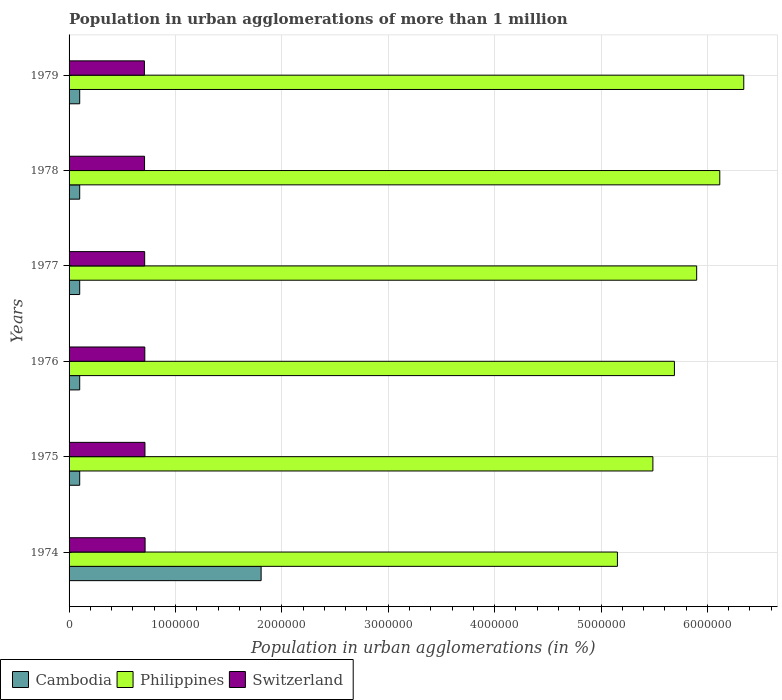How many different coloured bars are there?
Offer a terse response. 3. How many bars are there on the 2nd tick from the top?
Ensure brevity in your answer.  3. What is the label of the 1st group of bars from the top?
Offer a terse response. 1979. In how many cases, is the number of bars for a given year not equal to the number of legend labels?
Provide a succinct answer. 0. What is the population in urban agglomerations in Philippines in 1978?
Make the answer very short. 6.12e+06. Across all years, what is the maximum population in urban agglomerations in Switzerland?
Offer a terse response. 7.15e+05. Across all years, what is the minimum population in urban agglomerations in Philippines?
Offer a very short reply. 5.15e+06. In which year was the population in urban agglomerations in Cambodia maximum?
Your response must be concise. 1974. In which year was the population in urban agglomerations in Philippines minimum?
Offer a very short reply. 1974. What is the total population in urban agglomerations in Switzerland in the graph?
Your response must be concise. 4.27e+06. What is the difference between the population in urban agglomerations in Cambodia in 1978 and the population in urban agglomerations in Philippines in 1976?
Provide a succinct answer. -5.59e+06. What is the average population in urban agglomerations in Cambodia per year?
Keep it short and to the point. 3.84e+05. In the year 1976, what is the difference between the population in urban agglomerations in Switzerland and population in urban agglomerations in Cambodia?
Keep it short and to the point. 6.12e+05. What is the difference between the highest and the second highest population in urban agglomerations in Cambodia?
Ensure brevity in your answer.  1.71e+06. What is the difference between the highest and the lowest population in urban agglomerations in Cambodia?
Offer a very short reply. 1.71e+06. What does the 2nd bar from the top in 1979 represents?
Your answer should be very brief. Philippines. Is it the case that in every year, the sum of the population in urban agglomerations in Switzerland and population in urban agglomerations in Cambodia is greater than the population in urban agglomerations in Philippines?
Keep it short and to the point. No. How many years are there in the graph?
Provide a succinct answer. 6. Are the values on the major ticks of X-axis written in scientific E-notation?
Offer a very short reply. No. How many legend labels are there?
Make the answer very short. 3. What is the title of the graph?
Provide a succinct answer. Population in urban agglomerations of more than 1 million. Does "American Samoa" appear as one of the legend labels in the graph?
Your answer should be compact. No. What is the label or title of the X-axis?
Make the answer very short. Population in urban agglomerations (in %). What is the label or title of the Y-axis?
Ensure brevity in your answer.  Years. What is the Population in urban agglomerations (in %) of Cambodia in 1974?
Offer a terse response. 1.81e+06. What is the Population in urban agglomerations (in %) in Philippines in 1974?
Your answer should be compact. 5.15e+06. What is the Population in urban agglomerations (in %) in Switzerland in 1974?
Your answer should be very brief. 7.15e+05. What is the Population in urban agglomerations (in %) of Philippines in 1975?
Provide a succinct answer. 5.49e+06. What is the Population in urban agglomerations (in %) of Switzerland in 1975?
Your answer should be very brief. 7.13e+05. What is the Population in urban agglomerations (in %) in Cambodia in 1976?
Offer a very short reply. 1.00e+05. What is the Population in urban agglomerations (in %) in Philippines in 1976?
Make the answer very short. 5.69e+06. What is the Population in urban agglomerations (in %) in Switzerland in 1976?
Ensure brevity in your answer.  7.12e+05. What is the Population in urban agglomerations (in %) of Philippines in 1977?
Ensure brevity in your answer.  5.90e+06. What is the Population in urban agglomerations (in %) of Switzerland in 1977?
Ensure brevity in your answer.  7.11e+05. What is the Population in urban agglomerations (in %) of Philippines in 1978?
Ensure brevity in your answer.  6.12e+06. What is the Population in urban agglomerations (in %) of Switzerland in 1978?
Your answer should be compact. 7.09e+05. What is the Population in urban agglomerations (in %) in Philippines in 1979?
Give a very brief answer. 6.34e+06. What is the Population in urban agglomerations (in %) of Switzerland in 1979?
Provide a short and direct response. 7.08e+05. Across all years, what is the maximum Population in urban agglomerations (in %) in Cambodia?
Offer a very short reply. 1.81e+06. Across all years, what is the maximum Population in urban agglomerations (in %) of Philippines?
Offer a very short reply. 6.34e+06. Across all years, what is the maximum Population in urban agglomerations (in %) of Switzerland?
Your response must be concise. 7.15e+05. Across all years, what is the minimum Population in urban agglomerations (in %) of Philippines?
Make the answer very short. 5.15e+06. Across all years, what is the minimum Population in urban agglomerations (in %) in Switzerland?
Your answer should be very brief. 7.08e+05. What is the total Population in urban agglomerations (in %) of Cambodia in the graph?
Offer a terse response. 2.31e+06. What is the total Population in urban agglomerations (in %) of Philippines in the graph?
Keep it short and to the point. 3.47e+07. What is the total Population in urban agglomerations (in %) of Switzerland in the graph?
Keep it short and to the point. 4.27e+06. What is the difference between the Population in urban agglomerations (in %) of Cambodia in 1974 and that in 1975?
Give a very brief answer. 1.71e+06. What is the difference between the Population in urban agglomerations (in %) of Philippines in 1974 and that in 1975?
Offer a very short reply. -3.33e+05. What is the difference between the Population in urban agglomerations (in %) of Switzerland in 1974 and that in 1975?
Offer a terse response. 1312. What is the difference between the Population in urban agglomerations (in %) of Cambodia in 1974 and that in 1976?
Give a very brief answer. 1.71e+06. What is the difference between the Population in urban agglomerations (in %) of Philippines in 1974 and that in 1976?
Make the answer very short. -5.36e+05. What is the difference between the Population in urban agglomerations (in %) of Switzerland in 1974 and that in 1976?
Your response must be concise. 2623. What is the difference between the Population in urban agglomerations (in %) in Cambodia in 1974 and that in 1977?
Offer a very short reply. 1.71e+06. What is the difference between the Population in urban agglomerations (in %) in Philippines in 1974 and that in 1977?
Ensure brevity in your answer.  -7.45e+05. What is the difference between the Population in urban agglomerations (in %) of Switzerland in 1974 and that in 1977?
Your response must be concise. 3929. What is the difference between the Population in urban agglomerations (in %) of Cambodia in 1974 and that in 1978?
Your answer should be compact. 1.71e+06. What is the difference between the Population in urban agglomerations (in %) in Philippines in 1974 and that in 1978?
Provide a succinct answer. -9.62e+05. What is the difference between the Population in urban agglomerations (in %) in Switzerland in 1974 and that in 1978?
Make the answer very short. 5234. What is the difference between the Population in urban agglomerations (in %) in Cambodia in 1974 and that in 1979?
Make the answer very short. 1.71e+06. What is the difference between the Population in urban agglomerations (in %) in Philippines in 1974 and that in 1979?
Your response must be concise. -1.19e+06. What is the difference between the Population in urban agglomerations (in %) in Switzerland in 1974 and that in 1979?
Your response must be concise. 6537. What is the difference between the Population in urban agglomerations (in %) in Philippines in 1975 and that in 1976?
Offer a very short reply. -2.02e+05. What is the difference between the Population in urban agglomerations (in %) of Switzerland in 1975 and that in 1976?
Offer a very short reply. 1311. What is the difference between the Population in urban agglomerations (in %) in Philippines in 1975 and that in 1977?
Your response must be concise. -4.11e+05. What is the difference between the Population in urban agglomerations (in %) of Switzerland in 1975 and that in 1977?
Keep it short and to the point. 2617. What is the difference between the Population in urban agglomerations (in %) of Cambodia in 1975 and that in 1978?
Keep it short and to the point. 0. What is the difference between the Population in urban agglomerations (in %) of Philippines in 1975 and that in 1978?
Your answer should be very brief. -6.29e+05. What is the difference between the Population in urban agglomerations (in %) of Switzerland in 1975 and that in 1978?
Provide a succinct answer. 3922. What is the difference between the Population in urban agglomerations (in %) in Philippines in 1975 and that in 1979?
Keep it short and to the point. -8.54e+05. What is the difference between the Population in urban agglomerations (in %) in Switzerland in 1975 and that in 1979?
Give a very brief answer. 5225. What is the difference between the Population in urban agglomerations (in %) in Cambodia in 1976 and that in 1977?
Your response must be concise. 0. What is the difference between the Population in urban agglomerations (in %) in Philippines in 1976 and that in 1977?
Provide a succinct answer. -2.09e+05. What is the difference between the Population in urban agglomerations (in %) of Switzerland in 1976 and that in 1977?
Your answer should be very brief. 1306. What is the difference between the Population in urban agglomerations (in %) in Philippines in 1976 and that in 1978?
Provide a short and direct response. -4.26e+05. What is the difference between the Population in urban agglomerations (in %) of Switzerland in 1976 and that in 1978?
Your answer should be compact. 2611. What is the difference between the Population in urban agglomerations (in %) of Philippines in 1976 and that in 1979?
Provide a short and direct response. -6.52e+05. What is the difference between the Population in urban agglomerations (in %) in Switzerland in 1976 and that in 1979?
Ensure brevity in your answer.  3914. What is the difference between the Population in urban agglomerations (in %) of Philippines in 1977 and that in 1978?
Provide a short and direct response. -2.17e+05. What is the difference between the Population in urban agglomerations (in %) in Switzerland in 1977 and that in 1978?
Your answer should be very brief. 1305. What is the difference between the Population in urban agglomerations (in %) of Cambodia in 1977 and that in 1979?
Your answer should be very brief. 0. What is the difference between the Population in urban agglomerations (in %) in Philippines in 1977 and that in 1979?
Your answer should be compact. -4.43e+05. What is the difference between the Population in urban agglomerations (in %) in Switzerland in 1977 and that in 1979?
Offer a very short reply. 2608. What is the difference between the Population in urban agglomerations (in %) in Philippines in 1978 and that in 1979?
Offer a terse response. -2.25e+05. What is the difference between the Population in urban agglomerations (in %) of Switzerland in 1978 and that in 1979?
Provide a succinct answer. 1303. What is the difference between the Population in urban agglomerations (in %) of Cambodia in 1974 and the Population in urban agglomerations (in %) of Philippines in 1975?
Keep it short and to the point. -3.68e+06. What is the difference between the Population in urban agglomerations (in %) of Cambodia in 1974 and the Population in urban agglomerations (in %) of Switzerland in 1975?
Keep it short and to the point. 1.09e+06. What is the difference between the Population in urban agglomerations (in %) in Philippines in 1974 and the Population in urban agglomerations (in %) in Switzerland in 1975?
Your answer should be compact. 4.44e+06. What is the difference between the Population in urban agglomerations (in %) in Cambodia in 1974 and the Population in urban agglomerations (in %) in Philippines in 1976?
Your answer should be compact. -3.88e+06. What is the difference between the Population in urban agglomerations (in %) of Cambodia in 1974 and the Population in urban agglomerations (in %) of Switzerland in 1976?
Make the answer very short. 1.09e+06. What is the difference between the Population in urban agglomerations (in %) in Philippines in 1974 and the Population in urban agglomerations (in %) in Switzerland in 1976?
Provide a succinct answer. 4.44e+06. What is the difference between the Population in urban agglomerations (in %) in Cambodia in 1974 and the Population in urban agglomerations (in %) in Philippines in 1977?
Offer a terse response. -4.09e+06. What is the difference between the Population in urban agglomerations (in %) in Cambodia in 1974 and the Population in urban agglomerations (in %) in Switzerland in 1977?
Offer a very short reply. 1.09e+06. What is the difference between the Population in urban agglomerations (in %) in Philippines in 1974 and the Population in urban agglomerations (in %) in Switzerland in 1977?
Provide a short and direct response. 4.44e+06. What is the difference between the Population in urban agglomerations (in %) of Cambodia in 1974 and the Population in urban agglomerations (in %) of Philippines in 1978?
Ensure brevity in your answer.  -4.31e+06. What is the difference between the Population in urban agglomerations (in %) in Cambodia in 1974 and the Population in urban agglomerations (in %) in Switzerland in 1978?
Make the answer very short. 1.10e+06. What is the difference between the Population in urban agglomerations (in %) in Philippines in 1974 and the Population in urban agglomerations (in %) in Switzerland in 1978?
Your answer should be compact. 4.44e+06. What is the difference between the Population in urban agglomerations (in %) in Cambodia in 1974 and the Population in urban agglomerations (in %) in Philippines in 1979?
Your answer should be very brief. -4.54e+06. What is the difference between the Population in urban agglomerations (in %) of Cambodia in 1974 and the Population in urban agglomerations (in %) of Switzerland in 1979?
Offer a terse response. 1.10e+06. What is the difference between the Population in urban agglomerations (in %) in Philippines in 1974 and the Population in urban agglomerations (in %) in Switzerland in 1979?
Your answer should be compact. 4.45e+06. What is the difference between the Population in urban agglomerations (in %) in Cambodia in 1975 and the Population in urban agglomerations (in %) in Philippines in 1976?
Provide a short and direct response. -5.59e+06. What is the difference between the Population in urban agglomerations (in %) in Cambodia in 1975 and the Population in urban agglomerations (in %) in Switzerland in 1976?
Your response must be concise. -6.12e+05. What is the difference between the Population in urban agglomerations (in %) in Philippines in 1975 and the Population in urban agglomerations (in %) in Switzerland in 1976?
Make the answer very short. 4.78e+06. What is the difference between the Population in urban agglomerations (in %) of Cambodia in 1975 and the Population in urban agglomerations (in %) of Philippines in 1977?
Your answer should be compact. -5.80e+06. What is the difference between the Population in urban agglomerations (in %) of Cambodia in 1975 and the Population in urban agglomerations (in %) of Switzerland in 1977?
Offer a very short reply. -6.11e+05. What is the difference between the Population in urban agglomerations (in %) of Philippines in 1975 and the Population in urban agglomerations (in %) of Switzerland in 1977?
Offer a very short reply. 4.78e+06. What is the difference between the Population in urban agglomerations (in %) of Cambodia in 1975 and the Population in urban agglomerations (in %) of Philippines in 1978?
Your answer should be compact. -6.02e+06. What is the difference between the Population in urban agglomerations (in %) in Cambodia in 1975 and the Population in urban agglomerations (in %) in Switzerland in 1978?
Your answer should be very brief. -6.09e+05. What is the difference between the Population in urban agglomerations (in %) in Philippines in 1975 and the Population in urban agglomerations (in %) in Switzerland in 1978?
Your answer should be very brief. 4.78e+06. What is the difference between the Population in urban agglomerations (in %) of Cambodia in 1975 and the Population in urban agglomerations (in %) of Philippines in 1979?
Provide a short and direct response. -6.24e+06. What is the difference between the Population in urban agglomerations (in %) of Cambodia in 1975 and the Population in urban agglomerations (in %) of Switzerland in 1979?
Your answer should be very brief. -6.08e+05. What is the difference between the Population in urban agglomerations (in %) of Philippines in 1975 and the Population in urban agglomerations (in %) of Switzerland in 1979?
Give a very brief answer. 4.78e+06. What is the difference between the Population in urban agglomerations (in %) in Cambodia in 1976 and the Population in urban agglomerations (in %) in Philippines in 1977?
Offer a terse response. -5.80e+06. What is the difference between the Population in urban agglomerations (in %) of Cambodia in 1976 and the Population in urban agglomerations (in %) of Switzerland in 1977?
Make the answer very short. -6.11e+05. What is the difference between the Population in urban agglomerations (in %) in Philippines in 1976 and the Population in urban agglomerations (in %) in Switzerland in 1977?
Offer a very short reply. 4.98e+06. What is the difference between the Population in urban agglomerations (in %) of Cambodia in 1976 and the Population in urban agglomerations (in %) of Philippines in 1978?
Make the answer very short. -6.02e+06. What is the difference between the Population in urban agglomerations (in %) in Cambodia in 1976 and the Population in urban agglomerations (in %) in Switzerland in 1978?
Your answer should be very brief. -6.09e+05. What is the difference between the Population in urban agglomerations (in %) of Philippines in 1976 and the Population in urban agglomerations (in %) of Switzerland in 1978?
Offer a terse response. 4.98e+06. What is the difference between the Population in urban agglomerations (in %) of Cambodia in 1976 and the Population in urban agglomerations (in %) of Philippines in 1979?
Your answer should be compact. -6.24e+06. What is the difference between the Population in urban agglomerations (in %) of Cambodia in 1976 and the Population in urban agglomerations (in %) of Switzerland in 1979?
Your answer should be very brief. -6.08e+05. What is the difference between the Population in urban agglomerations (in %) in Philippines in 1976 and the Population in urban agglomerations (in %) in Switzerland in 1979?
Your answer should be compact. 4.98e+06. What is the difference between the Population in urban agglomerations (in %) in Cambodia in 1977 and the Population in urban agglomerations (in %) in Philippines in 1978?
Ensure brevity in your answer.  -6.02e+06. What is the difference between the Population in urban agglomerations (in %) in Cambodia in 1977 and the Population in urban agglomerations (in %) in Switzerland in 1978?
Offer a very short reply. -6.09e+05. What is the difference between the Population in urban agglomerations (in %) of Philippines in 1977 and the Population in urban agglomerations (in %) of Switzerland in 1978?
Make the answer very short. 5.19e+06. What is the difference between the Population in urban agglomerations (in %) in Cambodia in 1977 and the Population in urban agglomerations (in %) in Philippines in 1979?
Keep it short and to the point. -6.24e+06. What is the difference between the Population in urban agglomerations (in %) of Cambodia in 1977 and the Population in urban agglomerations (in %) of Switzerland in 1979?
Offer a terse response. -6.08e+05. What is the difference between the Population in urban agglomerations (in %) in Philippines in 1977 and the Population in urban agglomerations (in %) in Switzerland in 1979?
Give a very brief answer. 5.19e+06. What is the difference between the Population in urban agglomerations (in %) in Cambodia in 1978 and the Population in urban agglomerations (in %) in Philippines in 1979?
Keep it short and to the point. -6.24e+06. What is the difference between the Population in urban agglomerations (in %) of Cambodia in 1978 and the Population in urban agglomerations (in %) of Switzerland in 1979?
Your answer should be compact. -6.08e+05. What is the difference between the Population in urban agglomerations (in %) of Philippines in 1978 and the Population in urban agglomerations (in %) of Switzerland in 1979?
Make the answer very short. 5.41e+06. What is the average Population in urban agglomerations (in %) of Cambodia per year?
Your answer should be very brief. 3.84e+05. What is the average Population in urban agglomerations (in %) in Philippines per year?
Your answer should be very brief. 5.78e+06. What is the average Population in urban agglomerations (in %) in Switzerland per year?
Ensure brevity in your answer.  7.11e+05. In the year 1974, what is the difference between the Population in urban agglomerations (in %) of Cambodia and Population in urban agglomerations (in %) of Philippines?
Offer a very short reply. -3.35e+06. In the year 1974, what is the difference between the Population in urban agglomerations (in %) in Cambodia and Population in urban agglomerations (in %) in Switzerland?
Provide a short and direct response. 1.09e+06. In the year 1974, what is the difference between the Population in urban agglomerations (in %) of Philippines and Population in urban agglomerations (in %) of Switzerland?
Your answer should be compact. 4.44e+06. In the year 1975, what is the difference between the Population in urban agglomerations (in %) of Cambodia and Population in urban agglomerations (in %) of Philippines?
Keep it short and to the point. -5.39e+06. In the year 1975, what is the difference between the Population in urban agglomerations (in %) of Cambodia and Population in urban agglomerations (in %) of Switzerland?
Your answer should be very brief. -6.13e+05. In the year 1975, what is the difference between the Population in urban agglomerations (in %) in Philippines and Population in urban agglomerations (in %) in Switzerland?
Ensure brevity in your answer.  4.77e+06. In the year 1976, what is the difference between the Population in urban agglomerations (in %) in Cambodia and Population in urban agglomerations (in %) in Philippines?
Your answer should be very brief. -5.59e+06. In the year 1976, what is the difference between the Population in urban agglomerations (in %) of Cambodia and Population in urban agglomerations (in %) of Switzerland?
Ensure brevity in your answer.  -6.12e+05. In the year 1976, what is the difference between the Population in urban agglomerations (in %) of Philippines and Population in urban agglomerations (in %) of Switzerland?
Provide a succinct answer. 4.98e+06. In the year 1977, what is the difference between the Population in urban agglomerations (in %) of Cambodia and Population in urban agglomerations (in %) of Philippines?
Give a very brief answer. -5.80e+06. In the year 1977, what is the difference between the Population in urban agglomerations (in %) of Cambodia and Population in urban agglomerations (in %) of Switzerland?
Ensure brevity in your answer.  -6.11e+05. In the year 1977, what is the difference between the Population in urban agglomerations (in %) of Philippines and Population in urban agglomerations (in %) of Switzerland?
Your answer should be very brief. 5.19e+06. In the year 1978, what is the difference between the Population in urban agglomerations (in %) of Cambodia and Population in urban agglomerations (in %) of Philippines?
Provide a short and direct response. -6.02e+06. In the year 1978, what is the difference between the Population in urban agglomerations (in %) of Cambodia and Population in urban agglomerations (in %) of Switzerland?
Keep it short and to the point. -6.09e+05. In the year 1978, what is the difference between the Population in urban agglomerations (in %) in Philippines and Population in urban agglomerations (in %) in Switzerland?
Ensure brevity in your answer.  5.41e+06. In the year 1979, what is the difference between the Population in urban agglomerations (in %) of Cambodia and Population in urban agglomerations (in %) of Philippines?
Keep it short and to the point. -6.24e+06. In the year 1979, what is the difference between the Population in urban agglomerations (in %) of Cambodia and Population in urban agglomerations (in %) of Switzerland?
Provide a short and direct response. -6.08e+05. In the year 1979, what is the difference between the Population in urban agglomerations (in %) in Philippines and Population in urban agglomerations (in %) in Switzerland?
Offer a very short reply. 5.63e+06. What is the ratio of the Population in urban agglomerations (in %) of Cambodia in 1974 to that in 1975?
Ensure brevity in your answer.  18.05. What is the ratio of the Population in urban agglomerations (in %) in Philippines in 1974 to that in 1975?
Give a very brief answer. 0.94. What is the ratio of the Population in urban agglomerations (in %) in Switzerland in 1974 to that in 1975?
Give a very brief answer. 1. What is the ratio of the Population in urban agglomerations (in %) in Cambodia in 1974 to that in 1976?
Provide a short and direct response. 18.05. What is the ratio of the Population in urban agglomerations (in %) of Philippines in 1974 to that in 1976?
Offer a very short reply. 0.91. What is the ratio of the Population in urban agglomerations (in %) in Switzerland in 1974 to that in 1976?
Offer a terse response. 1. What is the ratio of the Population in urban agglomerations (in %) in Cambodia in 1974 to that in 1977?
Offer a terse response. 18.05. What is the ratio of the Population in urban agglomerations (in %) of Philippines in 1974 to that in 1977?
Offer a terse response. 0.87. What is the ratio of the Population in urban agglomerations (in %) of Switzerland in 1974 to that in 1977?
Offer a very short reply. 1.01. What is the ratio of the Population in urban agglomerations (in %) of Cambodia in 1974 to that in 1978?
Give a very brief answer. 18.05. What is the ratio of the Population in urban agglomerations (in %) in Philippines in 1974 to that in 1978?
Make the answer very short. 0.84. What is the ratio of the Population in urban agglomerations (in %) of Switzerland in 1974 to that in 1978?
Ensure brevity in your answer.  1.01. What is the ratio of the Population in urban agglomerations (in %) in Cambodia in 1974 to that in 1979?
Ensure brevity in your answer.  18.05. What is the ratio of the Population in urban agglomerations (in %) of Philippines in 1974 to that in 1979?
Make the answer very short. 0.81. What is the ratio of the Population in urban agglomerations (in %) of Switzerland in 1974 to that in 1979?
Provide a succinct answer. 1.01. What is the ratio of the Population in urban agglomerations (in %) of Philippines in 1975 to that in 1976?
Your response must be concise. 0.96. What is the ratio of the Population in urban agglomerations (in %) in Cambodia in 1975 to that in 1977?
Provide a succinct answer. 1. What is the ratio of the Population in urban agglomerations (in %) in Philippines in 1975 to that in 1977?
Your answer should be very brief. 0.93. What is the ratio of the Population in urban agglomerations (in %) of Switzerland in 1975 to that in 1977?
Provide a short and direct response. 1. What is the ratio of the Population in urban agglomerations (in %) in Cambodia in 1975 to that in 1978?
Provide a short and direct response. 1. What is the ratio of the Population in urban agglomerations (in %) of Philippines in 1975 to that in 1978?
Keep it short and to the point. 0.9. What is the ratio of the Population in urban agglomerations (in %) in Switzerland in 1975 to that in 1978?
Offer a terse response. 1.01. What is the ratio of the Population in urban agglomerations (in %) of Cambodia in 1975 to that in 1979?
Your response must be concise. 1. What is the ratio of the Population in urban agglomerations (in %) in Philippines in 1975 to that in 1979?
Offer a very short reply. 0.87. What is the ratio of the Population in urban agglomerations (in %) in Switzerland in 1975 to that in 1979?
Ensure brevity in your answer.  1.01. What is the ratio of the Population in urban agglomerations (in %) in Philippines in 1976 to that in 1977?
Make the answer very short. 0.96. What is the ratio of the Population in urban agglomerations (in %) in Cambodia in 1976 to that in 1978?
Provide a short and direct response. 1. What is the ratio of the Population in urban agglomerations (in %) in Philippines in 1976 to that in 1978?
Your answer should be very brief. 0.93. What is the ratio of the Population in urban agglomerations (in %) in Cambodia in 1976 to that in 1979?
Keep it short and to the point. 1. What is the ratio of the Population in urban agglomerations (in %) of Philippines in 1976 to that in 1979?
Your answer should be very brief. 0.9. What is the ratio of the Population in urban agglomerations (in %) in Cambodia in 1977 to that in 1978?
Provide a short and direct response. 1. What is the ratio of the Population in urban agglomerations (in %) in Philippines in 1977 to that in 1978?
Your response must be concise. 0.96. What is the ratio of the Population in urban agglomerations (in %) of Cambodia in 1977 to that in 1979?
Offer a terse response. 1. What is the ratio of the Population in urban agglomerations (in %) in Philippines in 1977 to that in 1979?
Provide a succinct answer. 0.93. What is the ratio of the Population in urban agglomerations (in %) in Philippines in 1978 to that in 1979?
Make the answer very short. 0.96. What is the difference between the highest and the second highest Population in urban agglomerations (in %) in Cambodia?
Your response must be concise. 1.71e+06. What is the difference between the highest and the second highest Population in urban agglomerations (in %) of Philippines?
Make the answer very short. 2.25e+05. What is the difference between the highest and the second highest Population in urban agglomerations (in %) of Switzerland?
Offer a very short reply. 1312. What is the difference between the highest and the lowest Population in urban agglomerations (in %) of Cambodia?
Ensure brevity in your answer.  1.71e+06. What is the difference between the highest and the lowest Population in urban agglomerations (in %) in Philippines?
Offer a terse response. 1.19e+06. What is the difference between the highest and the lowest Population in urban agglomerations (in %) in Switzerland?
Ensure brevity in your answer.  6537. 